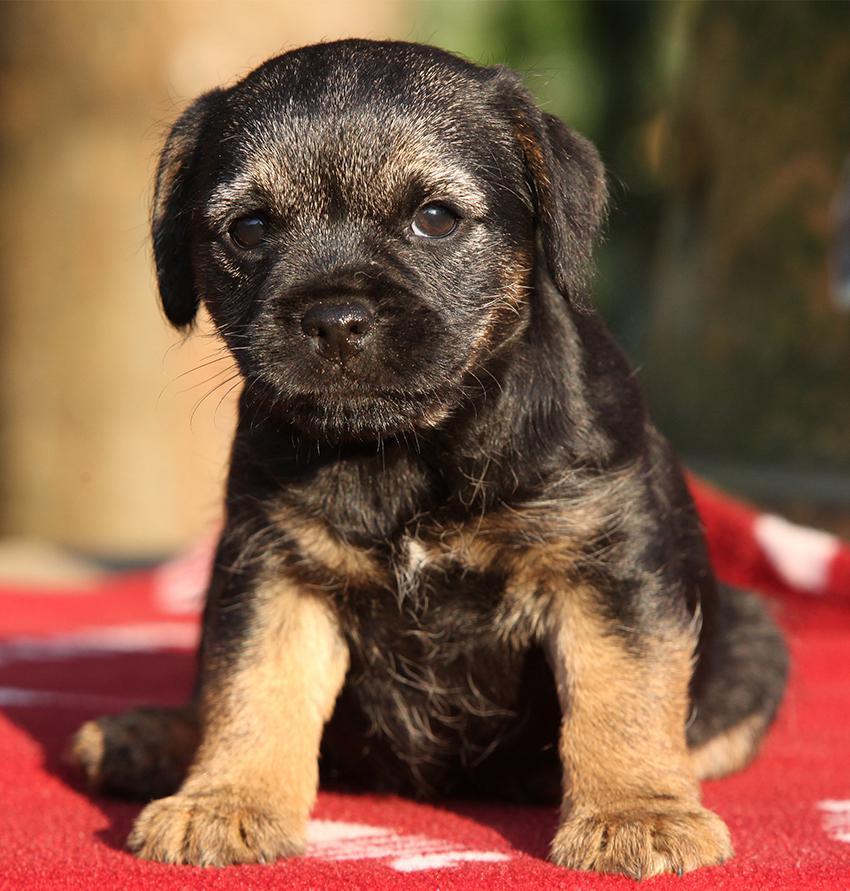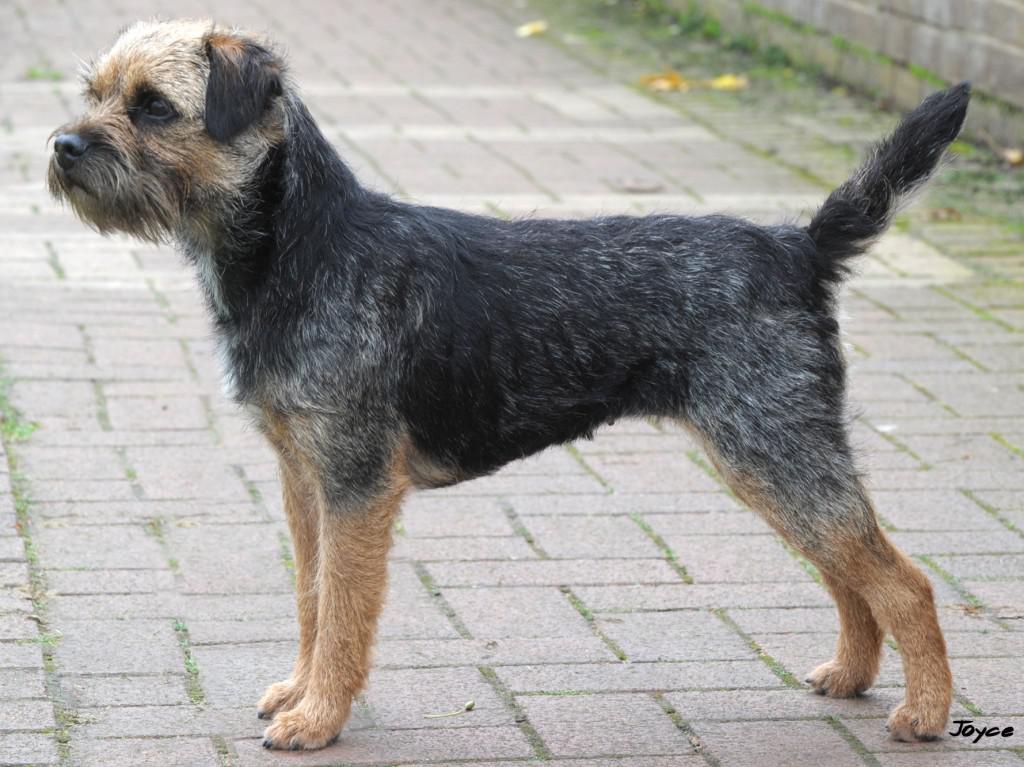The first image is the image on the left, the second image is the image on the right. For the images shown, is this caption "The left and right image contains the same number of dogs standing in the grass." true? Answer yes or no. No. The first image is the image on the left, the second image is the image on the right. Considering the images on both sides, is "The right image contains one dog standing with its head and body in profile turned leftward, with all paws on the ground, its mouth closed, and its tail straight and extended." valid? Answer yes or no. Yes. 